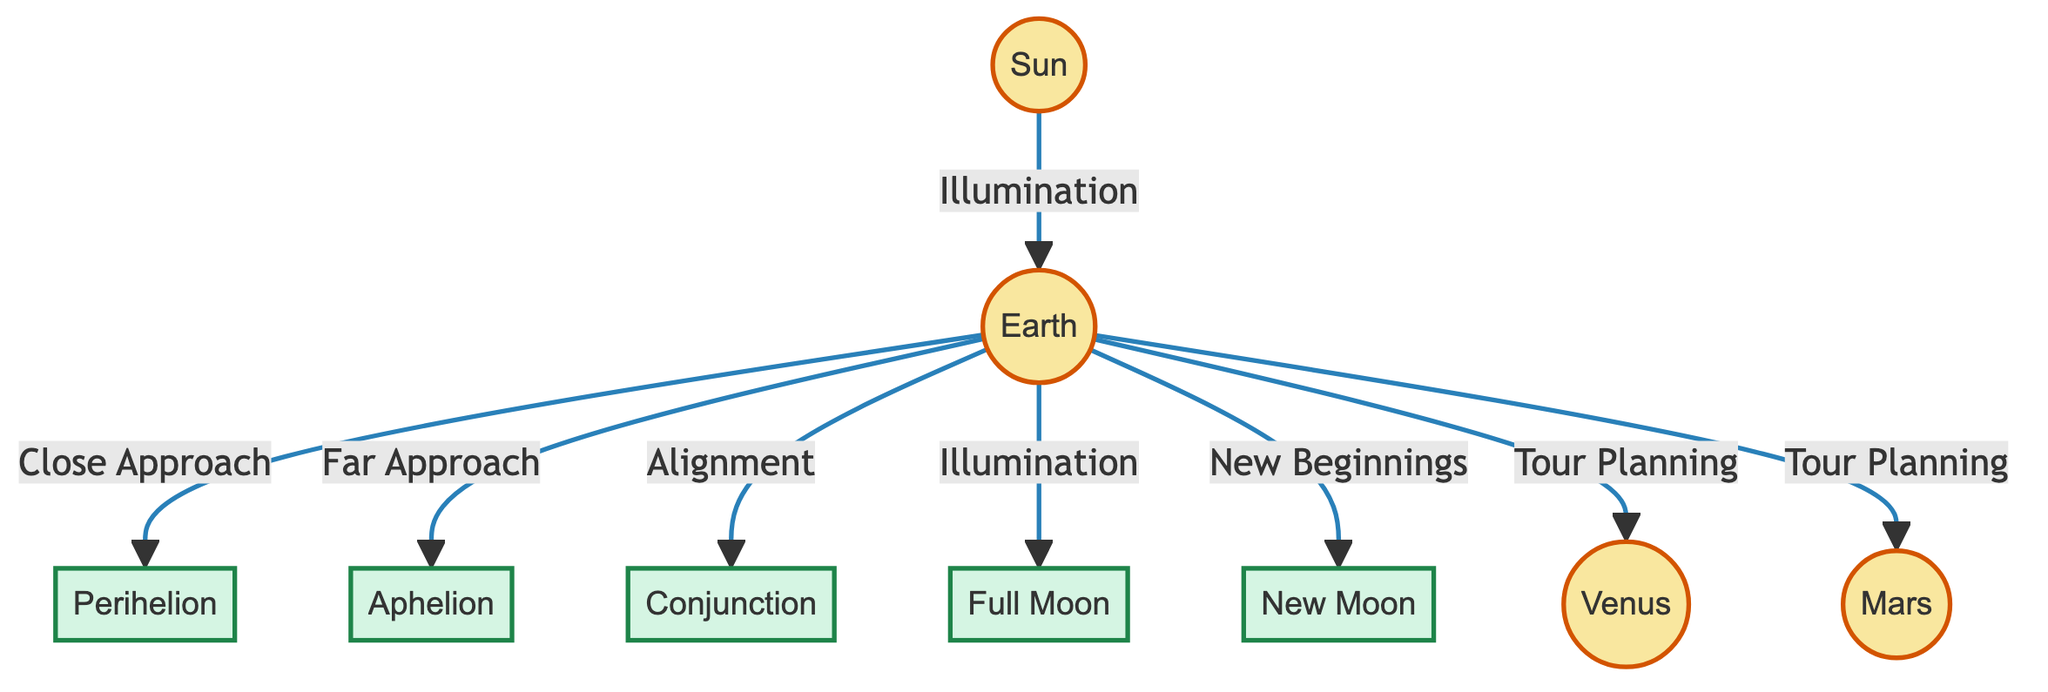What is the main celestial body shown in the diagram? The diagram prominently features the Sun as the central celestial body, indicated by its position and larger size compared to the other nodes.
Answer: Sun How many planets are connected to Earth in the diagram? The diagram shows Earth connected to two planets: Venus and Mars, as evidenced by the direct links from Earth to each planet.
Answer: 2 What event is associated with the closest approach of Earth to the Sun? The diagram specifies "Perihelion" as the event correlated with Earth's closest approach to the Sun, indicated by the directional connection from Earth to Perihelion.
Answer: Perihelion Which lunar phase is indicated as a time of "New Beginnings"? The diagram identifies "New Moon" as the phase associated with the concept of "New Beginnings" through its direct link to Earth.
Answer: New Moon What is the relationship between Earth and the event labeled "Full Moon"? The diagram displays a connection from Earth to the event labeled "Full Moon," indicating an illumination relationship, suggesting that the full moon occurs during a specific alignment as Earth orbits.
Answer: Illumination What celestial body is connected to Earth for tour planning? The diagram illustrates that both Venus and Mars are nodes linked to Earth under the "Tour Planning" relationship, indicating these planets are considered in shaping plans for events.
Answer: Venus, Mars What type of event is "Conjunction" in relation to Earth? The diagram indicates that "Conjunction" is associated with an alignment between Earth and another celestial body, establishing a significant interplay during their orbits.
Answer: Alignment How does Earth relate to its farthest approach from the Sun? The relationship shown in the diagram indicates that “Aphelion” represents the farthest distance of Earth from the Sun in the orbital path, characterized by a clear link from Earth to Aphelion.
Answer: Far Approach 